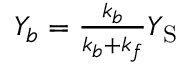<formula> <loc_0><loc_0><loc_500><loc_500>\begin{array} { r } { Y _ { b } = \frac { k _ { b } } { k _ { b } + k _ { f } } Y _ { S } } \end{array}</formula> 